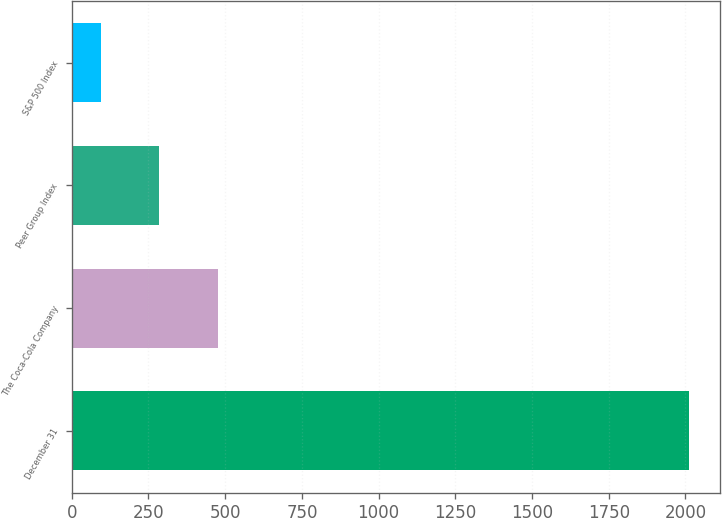Convert chart. <chart><loc_0><loc_0><loc_500><loc_500><bar_chart><fcel>December 31<fcel>The Coca-Cola Company<fcel>Peer Group Index<fcel>S&P 500 Index<nl><fcel>2011<fcel>477.4<fcel>285.7<fcel>94<nl></chart> 